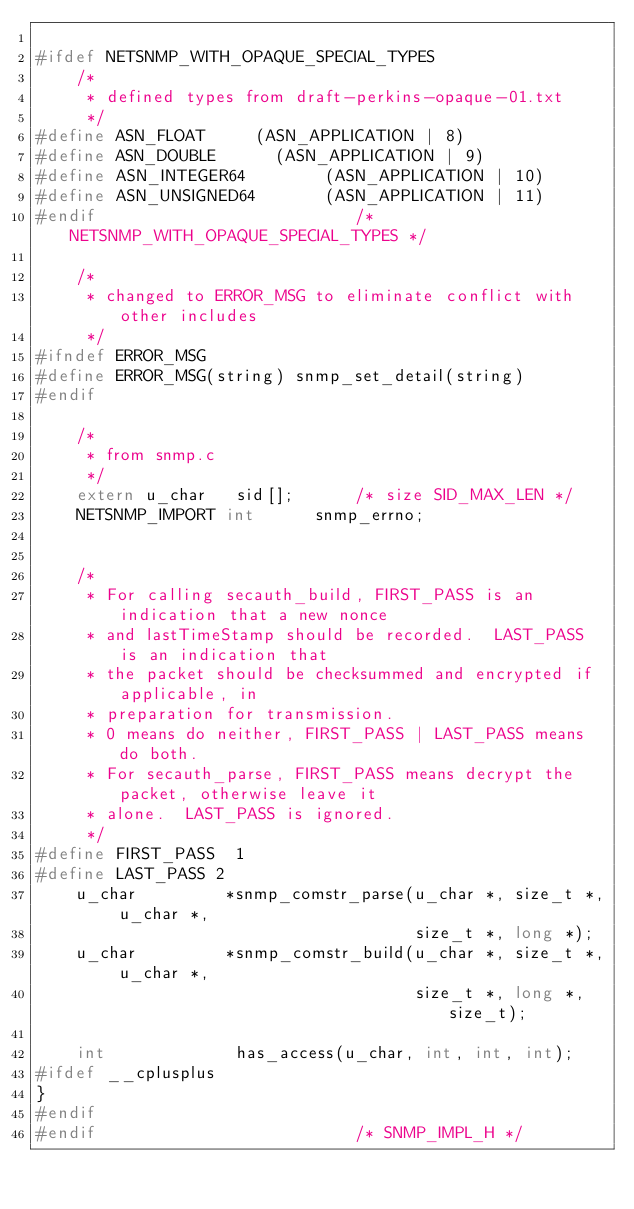Convert code to text. <code><loc_0><loc_0><loc_500><loc_500><_C_>
#ifdef NETSNMP_WITH_OPAQUE_SPECIAL_TYPES
    /*
     * defined types from draft-perkins-opaque-01.txt 
     */
#define ASN_FLOAT	    (ASN_APPLICATION | 8)
#define ASN_DOUBLE	    (ASN_APPLICATION | 9)
#define ASN_INTEGER64        (ASN_APPLICATION | 10)
#define ASN_UNSIGNED64       (ASN_APPLICATION | 11)
#endif                          /* NETSNMP_WITH_OPAQUE_SPECIAL_TYPES */

    /*
     * changed to ERROR_MSG to eliminate conflict with other includes 
     */
#ifndef ERROR_MSG
#define ERROR_MSG(string)	snmp_set_detail(string)
#endif

    /*
     * from snmp.c 
     */
    extern u_char   sid[];      /* size SID_MAX_LEN */
    NETSNMP_IMPORT int      snmp_errno;


    /*
     * For calling secauth_build, FIRST_PASS is an indication that a new nonce
     * and lastTimeStamp should be recorded.  LAST_PASS is an indication that
     * the packet should be checksummed and encrypted if applicable, in
     * preparation for transmission.
     * 0 means do neither, FIRST_PASS | LAST_PASS means do both.
     * For secauth_parse, FIRST_PASS means decrypt the packet, otherwise leave it
     * alone.  LAST_PASS is ignored.
     */
#define FIRST_PASS	1
#define	LAST_PASS	2
    u_char         *snmp_comstr_parse(u_char *, size_t *, u_char *,
                                      size_t *, long *);
    u_char         *snmp_comstr_build(u_char *, size_t *, u_char *,
                                      size_t *, long *, size_t);

    int             has_access(u_char, int, int, int);
#ifdef __cplusplus
}
#endif
#endif                          /* SNMP_IMPL_H */
</code> 